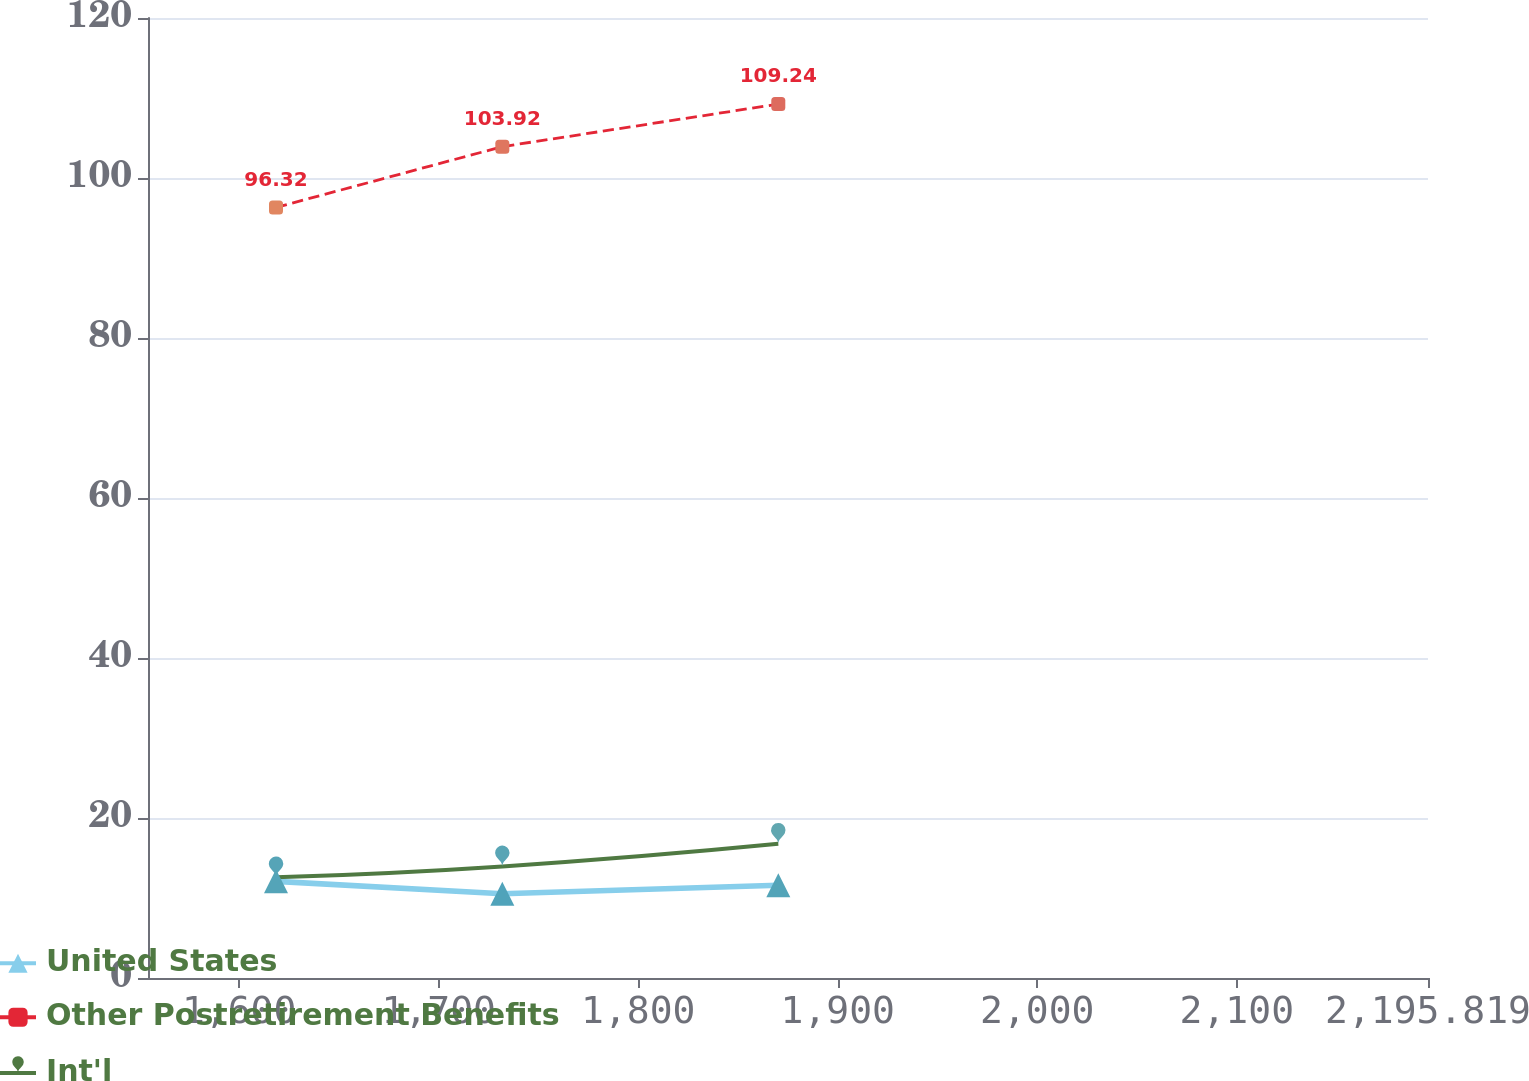<chart> <loc_0><loc_0><loc_500><loc_500><line_chart><ecel><fcel>United States<fcel>Other Postretirement Benefits<fcel>Int'l<nl><fcel>1618.46<fcel>12.08<fcel>96.32<fcel>12.58<nl><fcel>1731.89<fcel>10.54<fcel>103.92<fcel>13.94<nl><fcel>1870.2<fcel>11.6<fcel>109.24<fcel>16.77<nl><fcel>2198.62<fcel>11.37<fcel>122.44<fcel>13<nl><fcel>2259.97<fcel>12.88<fcel>101.31<fcel>13.52<nl></chart> 